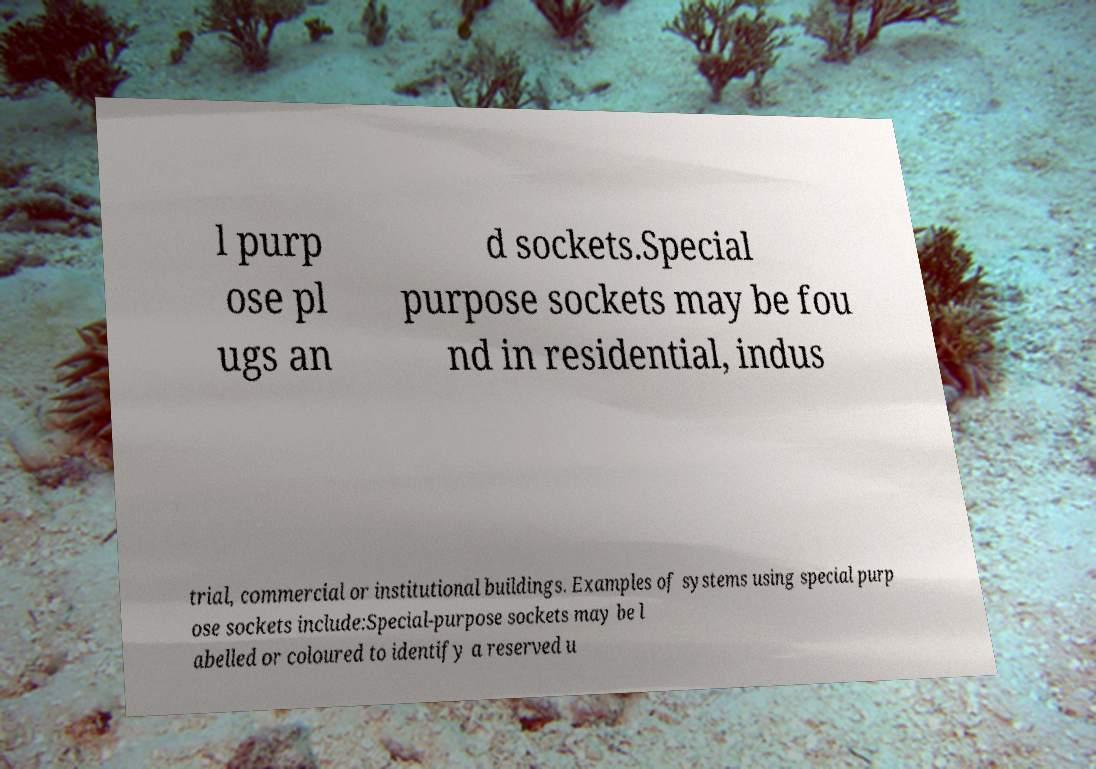Please identify and transcribe the text found in this image. l purp ose pl ugs an d sockets.Special purpose sockets may be fou nd in residential, indus trial, commercial or institutional buildings. Examples of systems using special purp ose sockets include:Special-purpose sockets may be l abelled or coloured to identify a reserved u 